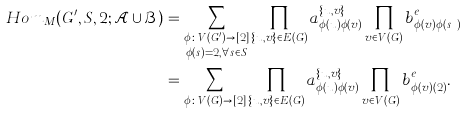Convert formula to latex. <formula><loc_0><loc_0><loc_500><loc_500>H o m _ { M } ( G ^ { \prime } , S , 2 ; \mathcal { A } \cup \mathcal { B } ) & = \sum _ { \substack { \phi \colon V ( G ^ { \prime } ) \to [ 2 ] \\ \phi ( s ) = 2 , \forall s \in S } } \prod _ { \{ u , v \} \in E ( G ) } a _ { \phi ( u ) \phi ( v ) } ^ { \{ u , v \} } \prod _ { v \in V ( G ) } b _ { \phi ( v ) \phi ( s _ { v } ) } ^ { e _ { v } } \\ & = \sum _ { \phi \colon V ( G ) \to [ 2 ] } \prod _ { \{ u , v \} \in E ( G ) } a _ { \phi ( u ) \phi ( v ) } ^ { \{ u , v \} } \prod _ { v \in V ( G ) } b _ { \phi ( v ) ( 2 ) } ^ { e _ { v } } .</formula> 